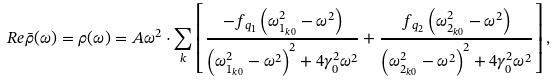Convert formula to latex. <formula><loc_0><loc_0><loc_500><loc_500>R e { \bar { \rho } } ( \omega ) = \rho ( \omega ) = A \omega ^ { 2 } \cdot \sum _ { k } \left [ \frac { - f _ { q _ { 1 } } \left ( \omega _ { 1 _ { k 0 } } ^ { 2 } - \omega ^ { 2 } \right ) } { \left ( \omega _ { 1 _ { k 0 } } ^ { 2 } - \omega ^ { 2 } \right ) ^ { 2 } + 4 \gamma _ { 0 } ^ { 2 } \omega ^ { 2 } } + \frac { f _ { q _ { 2 } } \left ( \omega _ { 2 _ { k 0 } } ^ { 2 } - \omega ^ { 2 } \right ) } { \left ( \omega _ { 2 _ { k 0 } } ^ { 2 } - \omega ^ { 2 } \right ) ^ { 2 } + 4 \gamma _ { 0 } ^ { 2 } \omega ^ { 2 } } \right ] , \\</formula> 